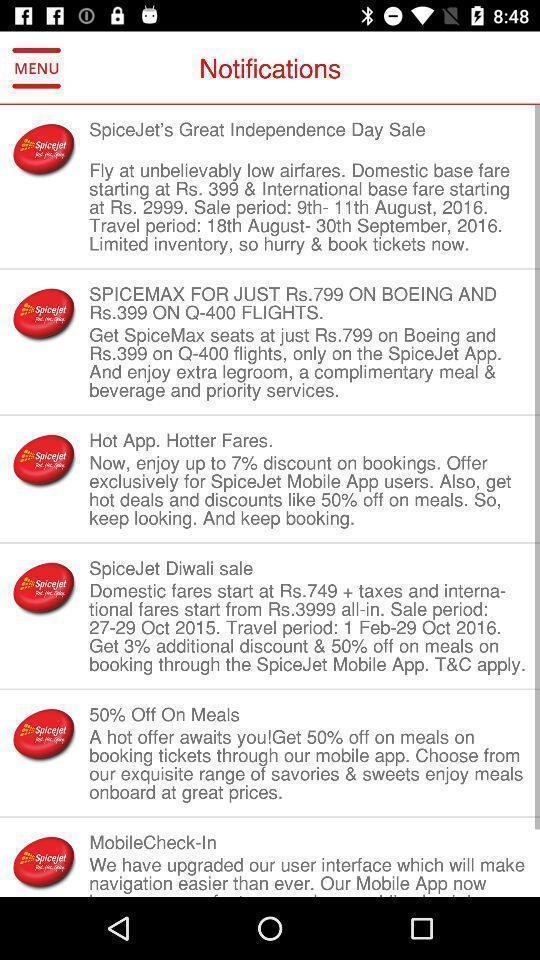Describe the key features of this screenshot. Screen shows list of notifications in a shopping app. 